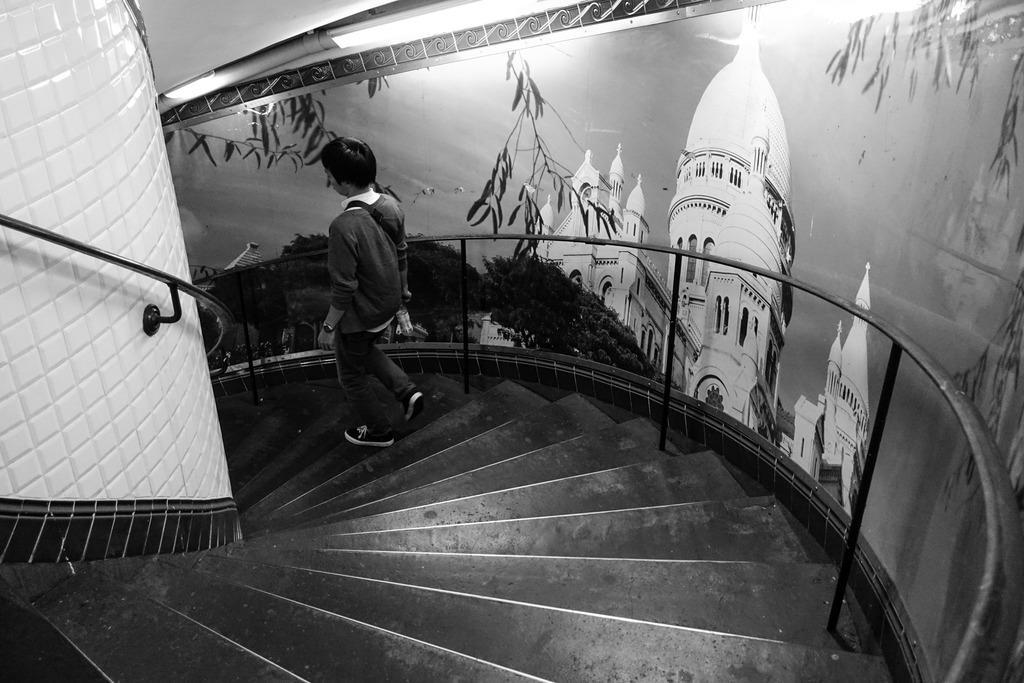How would you summarize this image in a sentence or two? In this image we can see there is a person walking on the stairs and holding a white color object. And there is a poster attached to the wall, in that there are trees and building. 